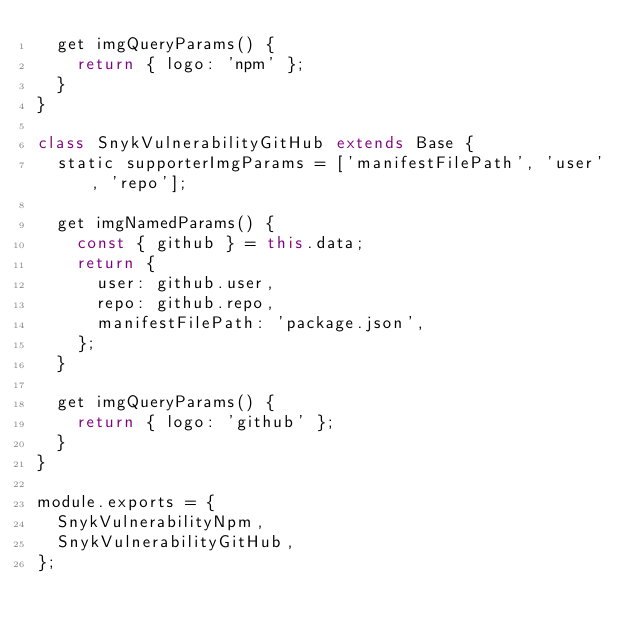Convert code to text. <code><loc_0><loc_0><loc_500><loc_500><_JavaScript_>  get imgQueryParams() {
    return { logo: 'npm' };
  }
}

class SnykVulnerabilityGitHub extends Base {
  static supporterImgParams = ['manifestFilePath', 'user', 'repo'];

  get imgNamedParams() {
    const { github } = this.data;
    return {
      user: github.user,
      repo: github.repo,
      manifestFilePath: 'package.json',
    };
  }

  get imgQueryParams() {
    return { logo: 'github' };
  }
}

module.exports = {
  SnykVulnerabilityNpm,
  SnykVulnerabilityGitHub,
};
</code> 